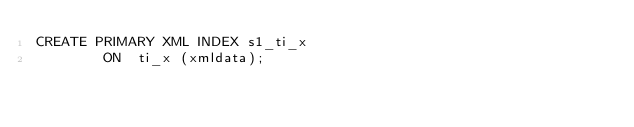<code> <loc_0><loc_0><loc_500><loc_500><_SQL_>CREATE PRIMARY XML INDEX s1_ti_x
		ON	ti_x (xmldata);
</code> 